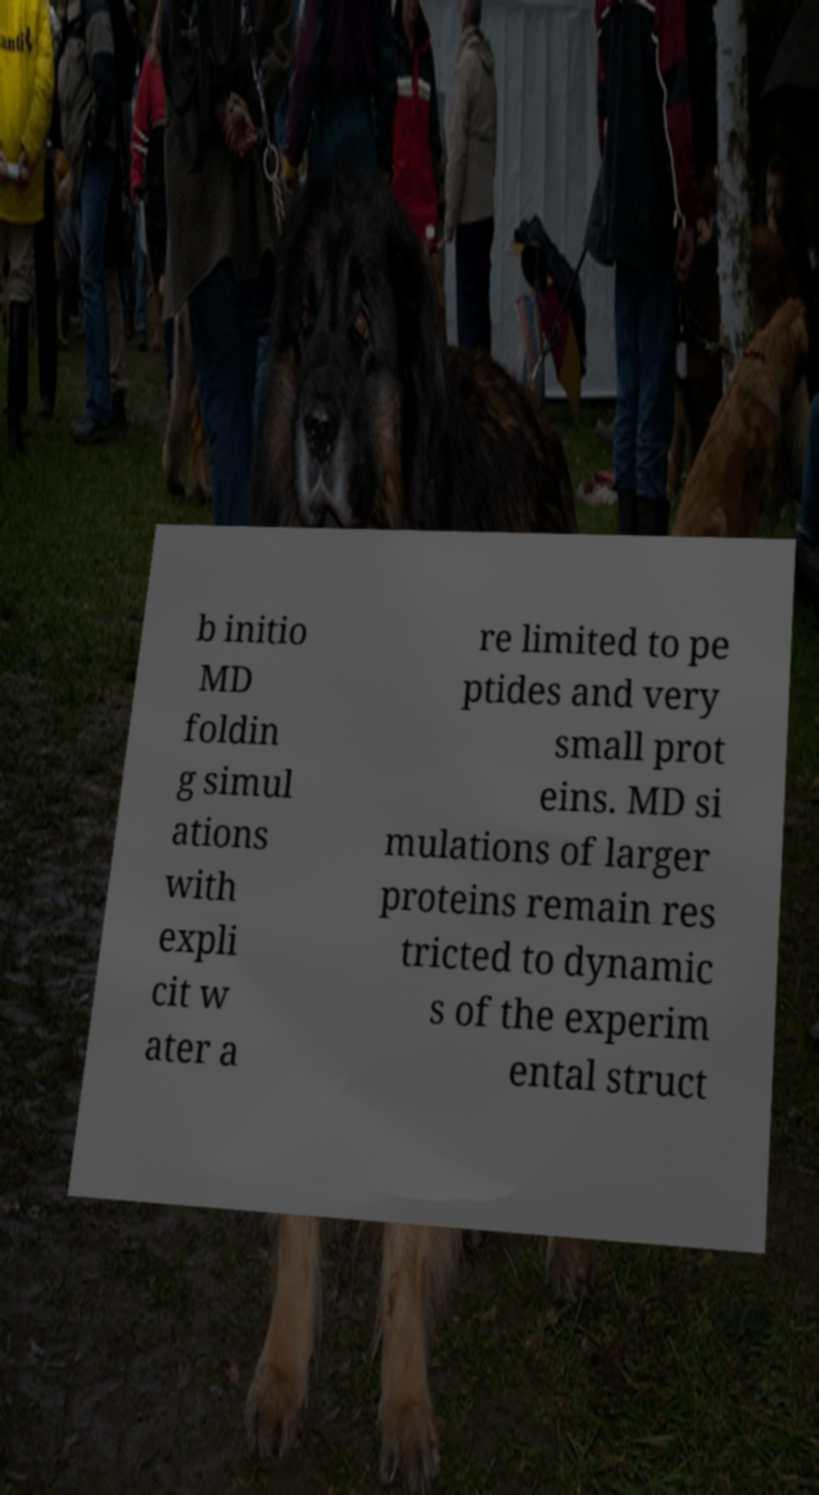Please identify and transcribe the text found in this image. b initio MD foldin g simul ations with expli cit w ater a re limited to pe ptides and very small prot eins. MD si mulations of larger proteins remain res tricted to dynamic s of the experim ental struct 